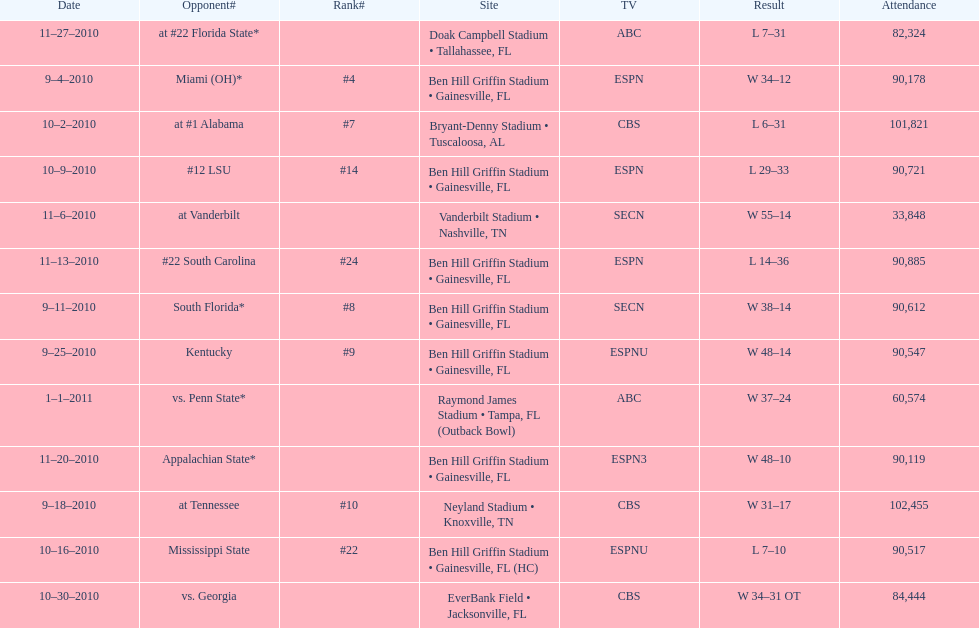What was the number of consecutive weeks the gators won in the 2010 season before they had their first loss? 4. 